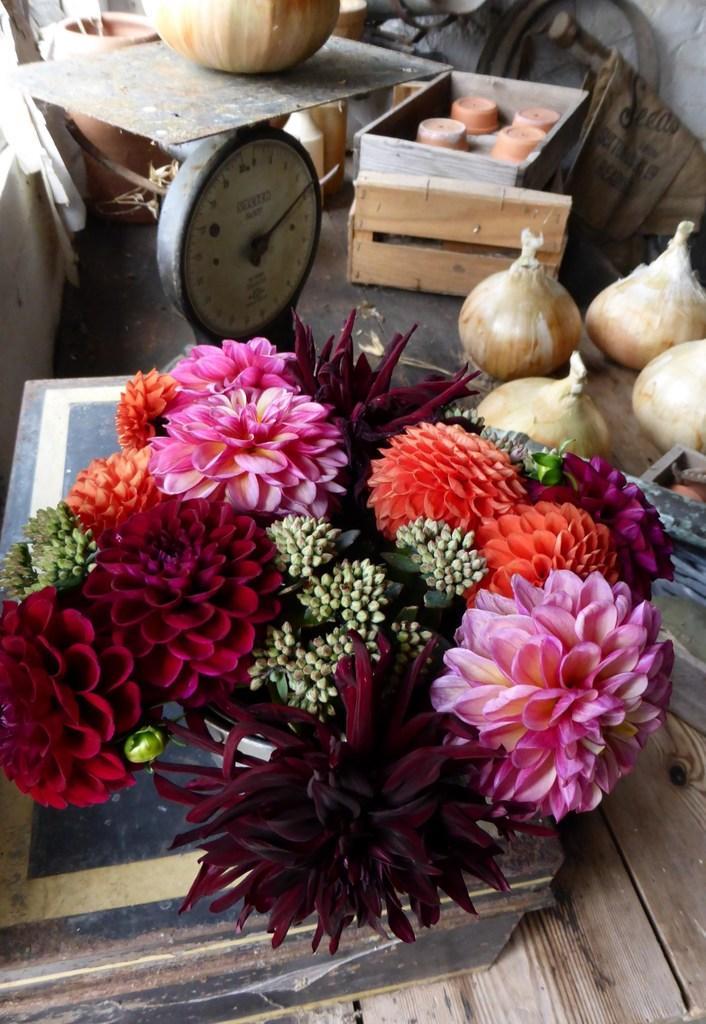Can you describe this image briefly? In this picture there are colorful flowers in the center of the image and there are onions on the right side of the image, there are wooden boxes at the top side of the image. 